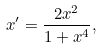Convert formula to latex. <formula><loc_0><loc_0><loc_500><loc_500>x ^ { \prime } = \frac { 2 x ^ { 2 } } { 1 + x ^ { 4 } } ,</formula> 